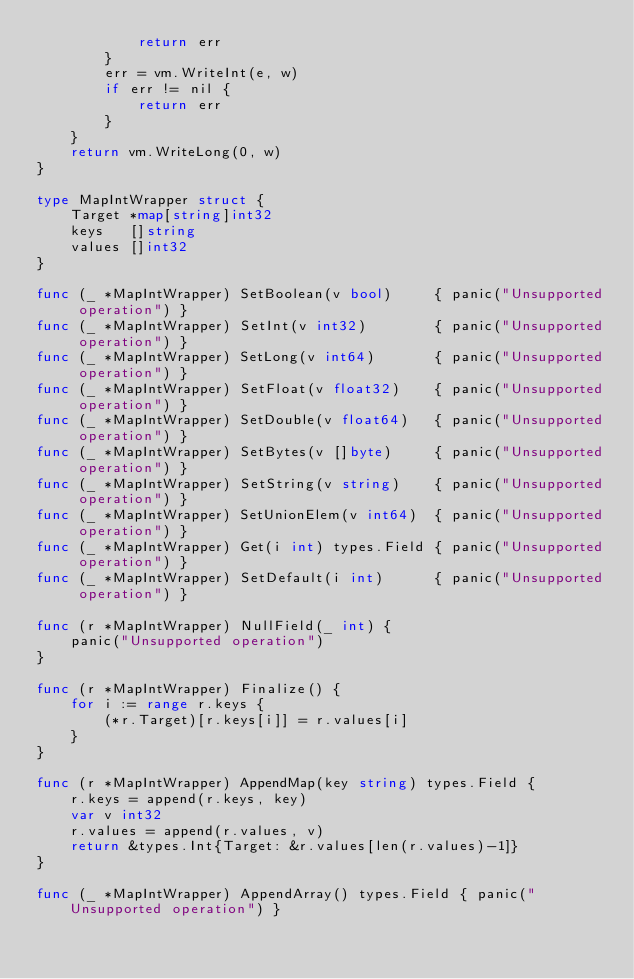Convert code to text. <code><loc_0><loc_0><loc_500><loc_500><_Go_>			return err
		}
		err = vm.WriteInt(e, w)
		if err != nil {
			return err
		}
	}
	return vm.WriteLong(0, w)
}

type MapIntWrapper struct {
	Target *map[string]int32
	keys   []string
	values []int32
}

func (_ *MapIntWrapper) SetBoolean(v bool)     { panic("Unsupported operation") }
func (_ *MapIntWrapper) SetInt(v int32)        { panic("Unsupported operation") }
func (_ *MapIntWrapper) SetLong(v int64)       { panic("Unsupported operation") }
func (_ *MapIntWrapper) SetFloat(v float32)    { panic("Unsupported operation") }
func (_ *MapIntWrapper) SetDouble(v float64)   { panic("Unsupported operation") }
func (_ *MapIntWrapper) SetBytes(v []byte)     { panic("Unsupported operation") }
func (_ *MapIntWrapper) SetString(v string)    { panic("Unsupported operation") }
func (_ *MapIntWrapper) SetUnionElem(v int64)  { panic("Unsupported operation") }
func (_ *MapIntWrapper) Get(i int) types.Field { panic("Unsupported operation") }
func (_ *MapIntWrapper) SetDefault(i int)      { panic("Unsupported operation") }

func (r *MapIntWrapper) NullField(_ int) {
	panic("Unsupported operation")
}

func (r *MapIntWrapper) Finalize() {
	for i := range r.keys {
		(*r.Target)[r.keys[i]] = r.values[i]
	}
}

func (r *MapIntWrapper) AppendMap(key string) types.Field {
	r.keys = append(r.keys, key)
	var v int32
	r.values = append(r.values, v)
	return &types.Int{Target: &r.values[len(r.values)-1]}
}

func (_ *MapIntWrapper) AppendArray() types.Field { panic("Unsupported operation") }
</code> 